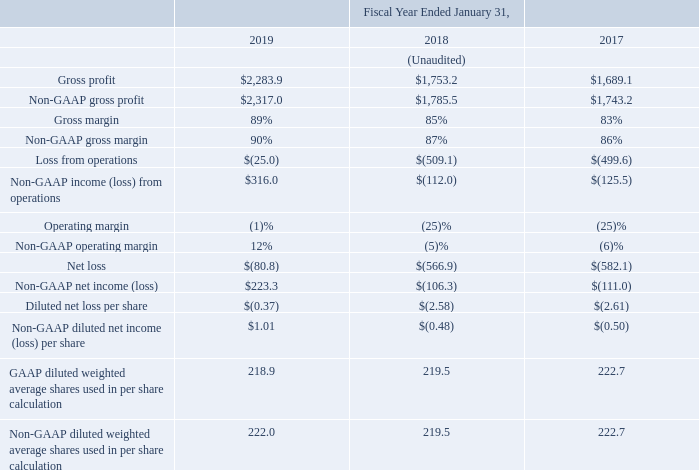OTHER FINANCIAL INFORMATION
In addition to our results determined under U.S. generally accepted accounting principles (“GAAP”) discussed above, we believe the following non-GAAP measures are useful to investors in evaluating our operating performance. For the fiscal years ended January 31, 2019, 2018, and 2017, our gross profit, gross margin, (loss) income from operations, operating margin, net (loss) income, diluted net (loss) income per share and diluted shares used in per share calculation on a GAAP and non-GAAP basis were as follows (in millions except for gross margin, operating margin, and per share data):
For our internal budgeting and resource allocation process and as a means to provide consistency in period-to-period comparisons, we use non-GAAP measures to supplement our consolidated financial statements presented on a GAAP basis. These non-GAAP measures do not include certain items that may have a material impact upon our reported financial results. We also use non-GAAP measures in making operating decisions because we believe those measures provide meaningful supplemental information regarding our earning potential and performance for management by excluding certain benefits, credits, expenses and charges that may not be indicative of our core business operating results. For the reasons set forth below, we believe these non-GAAP financial measures are useful to investors both because (1) they allow for greater transparency with respect to key metrics used by management in its financial and operational decision-making and (2) they are used by our institutional investors and the analyst community to help them analyze the health of our business. This allows investors and others to better understand and evaluate our operating results and future prospects in the same manner as management, compare financial results across accounting periods and to those of peer companies and to better understand the long-term performance of our core business. We also use some of these measures for purposes of determining company-wide incentive compensation.
There are limitations in using non-GAAP financial measures because non-GAAP financial measures are not prepared in accordance with GAAP and may be different from non-GAAP financial measures used by other companies. The non-GAAP financial measures included above are limited in value because they exclude certain items that may have a material impact upon our reported financial results. In addition, they are subject to inherent limitations as they reflect the exercise of judgments by management about which charges are excluded from the non-GAAP financial measures. We compensate for these limitations by analyzing current and future results on a GAAP basis as well as a non-GAAP basis and also by providing GAAP measures in our public disclosures. The presentation of non-GAAP financial information is meant to be considered in addition to, not as a substitute for or in isolation from, the directly comparable financial measures prepared in accordance with GAAP. We urge investors to review the reconciliation of our non-GAAP financial measures to the comparable GAAP financial measures included below, and not to rely on any single financial measure to evaluate our business.
What was the percentage increase in gross profit from 2018 to 2019?
Answer scale should be: percent. (2,283.9-1,753.2)/1,753.2
Answer: 30.27. What is the total sales in 2017?
Answer scale should be: million. 1,689.1/83% 
Answer: 2035.06. How does the company use non-GAAP measures? For our internal budgeting and resource allocation process and as a means to provide consistency in period-to-period comparisons, we use non-gaap measures to supplement our consolidated financial statements presented on a gaap basis. these non-gaap measures do not include certain items that may have a material impact upon our reported financial results. we also use non-gaap measures in making operating decisions because we believe those measures provide meaningful supplemental information regarding our earning potential and performance for management by excluding certain benefits, credits, expenses and charges that may not be indicative of our core business operating results. Why are these non-GAAP measures useful for investors? This allows investors and others to better understand and evaluate our operating results and future prospects in the same manner as management, compare financial results across accounting periods and to those of peer companies and to better understand the long-term performance of our core business. How much did gross margin change from fiscal year ending January 31, 2019 compared to the prior year?
Answer scale should be: percent. 89%-85% 
Answer: 4. What is the net loss in 2018? $(566.9). 